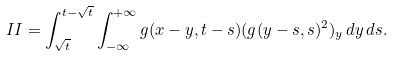Convert formula to latex. <formula><loc_0><loc_0><loc_500><loc_500>I I = \int _ { \sqrt { t } } ^ { t - \sqrt { t } } \int _ { - \infty } ^ { + \infty } g ( x - y , t - s ) ( g ( y - s , s ) ^ { 2 } ) _ { y } \, d y \, d s .</formula> 